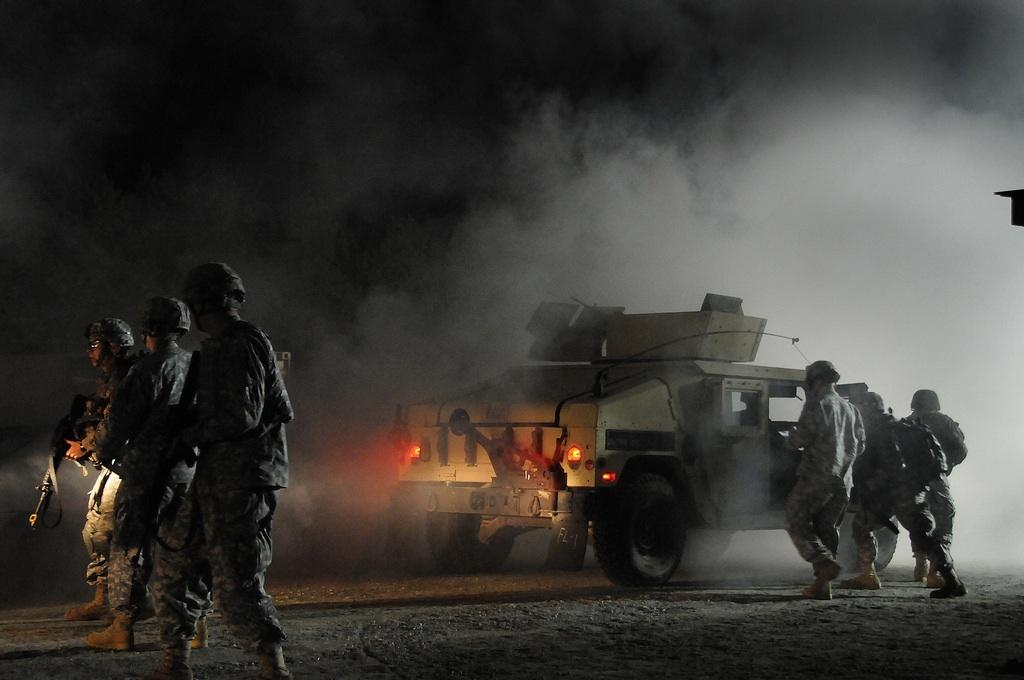How many people are in the group shown in the image? There is a group of people in the image, but the exact number is not specified. What are some people in the group wearing? Some people in the group are wearing helmets. What can be seen in the background of the image? There is a vehicle and smoke visible in the background of the image. What type of bean is being used for the activity in the image? There is no bean or activity involving a bean present in the image. 